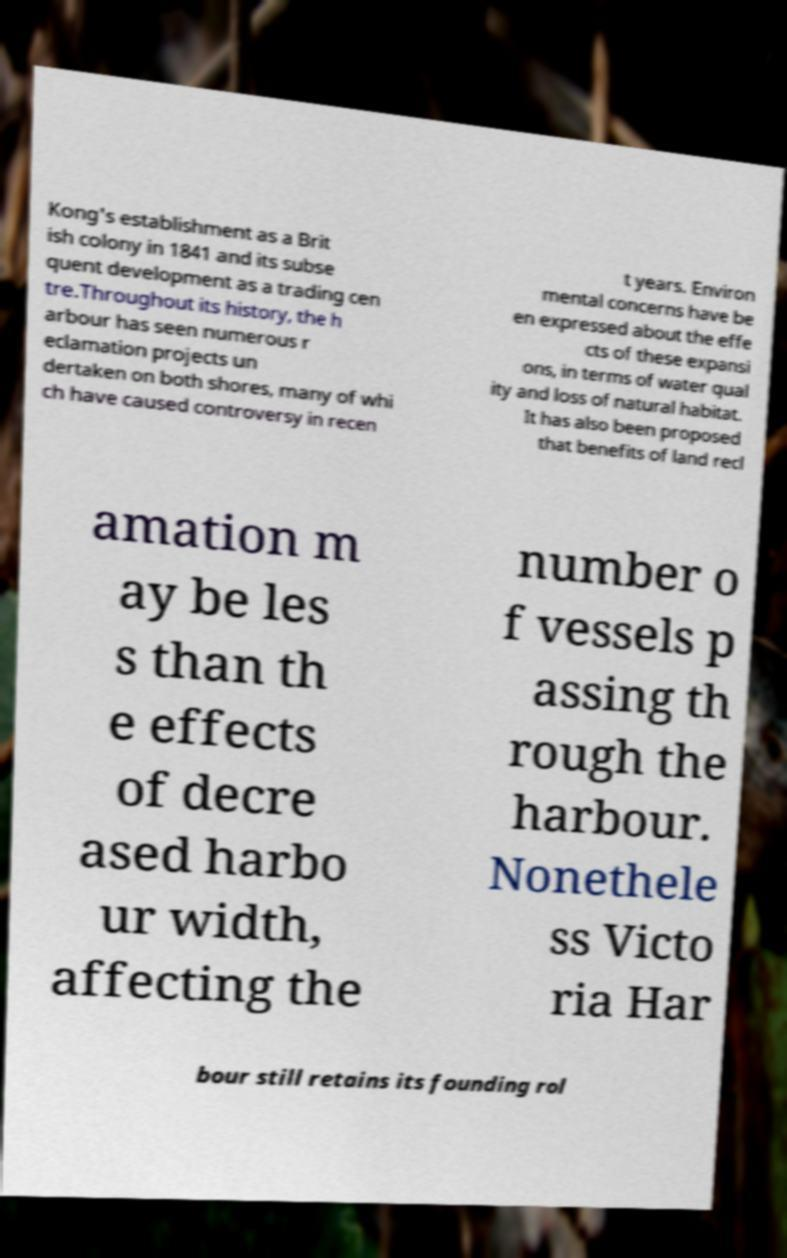Please read and relay the text visible in this image. What does it say? Kong's establishment as a Brit ish colony in 1841 and its subse quent development as a trading cen tre.Throughout its history, the h arbour has seen numerous r eclamation projects un dertaken on both shores, many of whi ch have caused controversy in recen t years. Environ mental concerns have be en expressed about the effe cts of these expansi ons, in terms of water qual ity and loss of natural habitat. It has also been proposed that benefits of land recl amation m ay be les s than th e effects of decre ased harbo ur width, affecting the number o f vessels p assing th rough the harbour. Nonethele ss Victo ria Har bour still retains its founding rol 